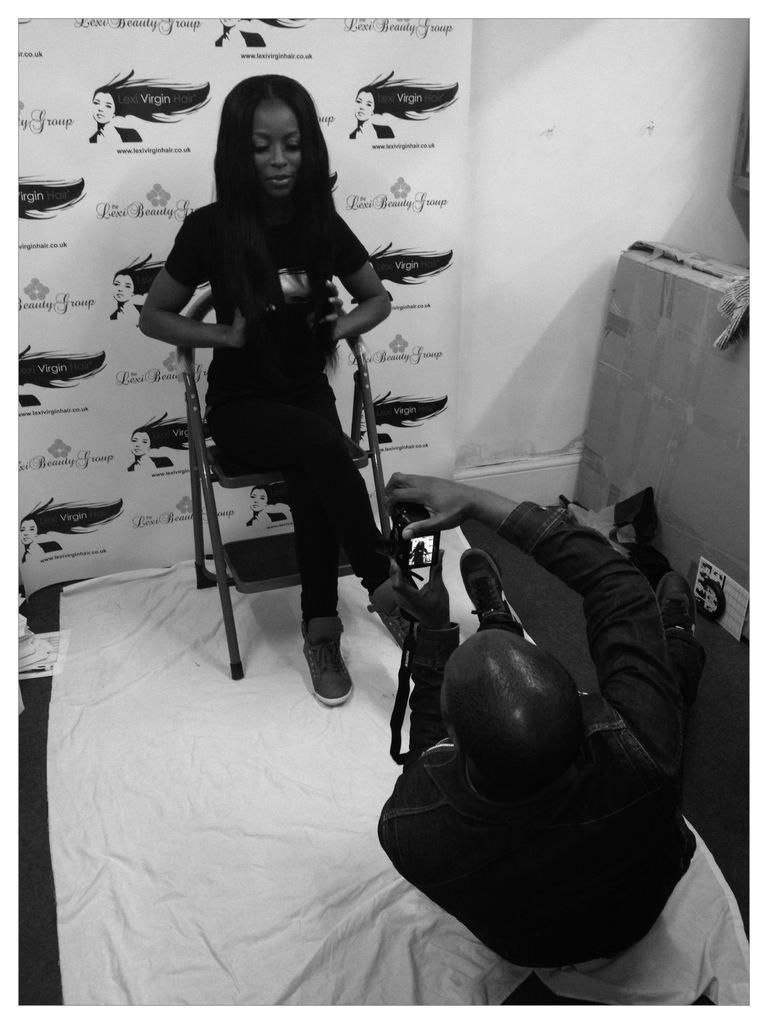Describe this image in one or two sentences. In this picture at the bottom we can see a person holding camera. In the middle there is a woman sitting in chair. In the background we can see a banner and wall. On the right there is a box. 